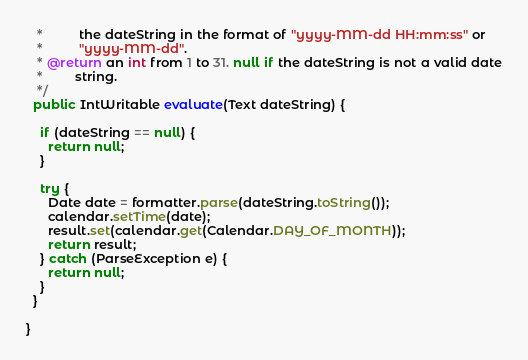<code> <loc_0><loc_0><loc_500><loc_500><_Java_>   *          the dateString in the format of "yyyy-MM-dd HH:mm:ss" or
   *          "yyyy-MM-dd".
   * @return an int from 1 to 31. null if the dateString is not a valid date
   *         string.
   */
  public IntWritable evaluate(Text dateString) {

    if (dateString == null) {
      return null;
    }

    try {
      Date date = formatter.parse(dateString.toString());
      calendar.setTime(date);
      result.set(calendar.get(Calendar.DAY_OF_MONTH));
      return result;
    } catch (ParseException e) {
      return null;
    }
  }

}
</code> 